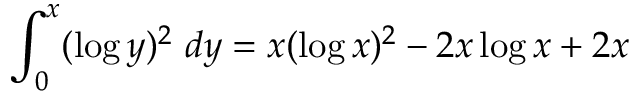Convert formula to latex. <formula><loc_0><loc_0><loc_500><loc_500>\int _ { 0 } ^ { x } ( \log y ) ^ { 2 } \ d y = x ( \log x ) ^ { 2 } - 2 x \log x + 2 x</formula> 